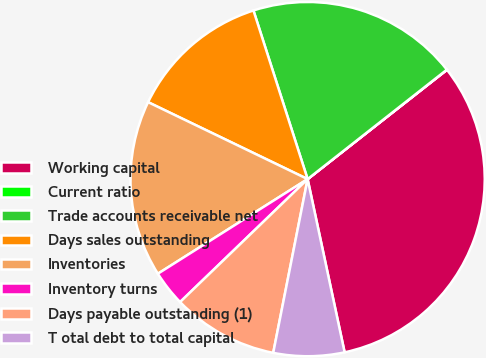Convert chart. <chart><loc_0><loc_0><loc_500><loc_500><pie_chart><fcel>Working capital<fcel>Current ratio<fcel>Trade accounts receivable net<fcel>Days sales outstanding<fcel>Inventories<fcel>Inventory turns<fcel>Days payable outstanding (1)<fcel>T otal debt to total capital<nl><fcel>32.23%<fcel>0.02%<fcel>19.34%<fcel>12.9%<fcel>16.12%<fcel>3.24%<fcel>9.68%<fcel>6.46%<nl></chart> 